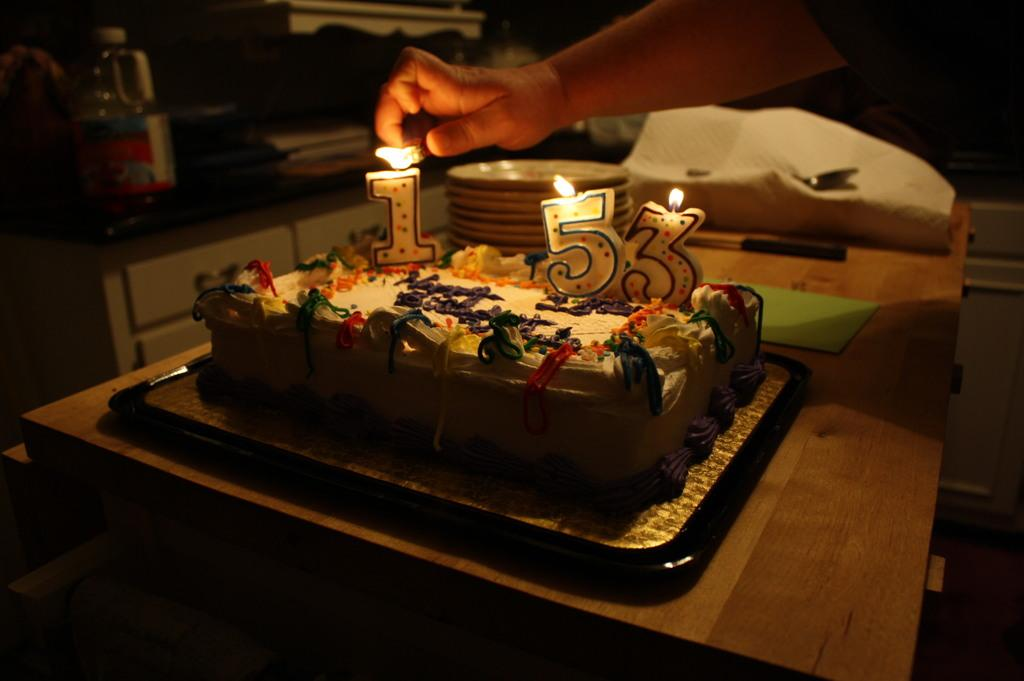What is the main food item visible in the image? There is a cake in the image. What objects might be used for serving or eating the cake? There are plates visible in the image. Can you describe any human presence in the image? A hand of a person is visible in the image. What type of toys can be seen scattered around the cake in the image? There are no toys present in the image; it only features a cake and plates. Can you describe the mountain range visible in the background of the image? There is no mountain range visible in the image; it is focused on the cake and plates. 